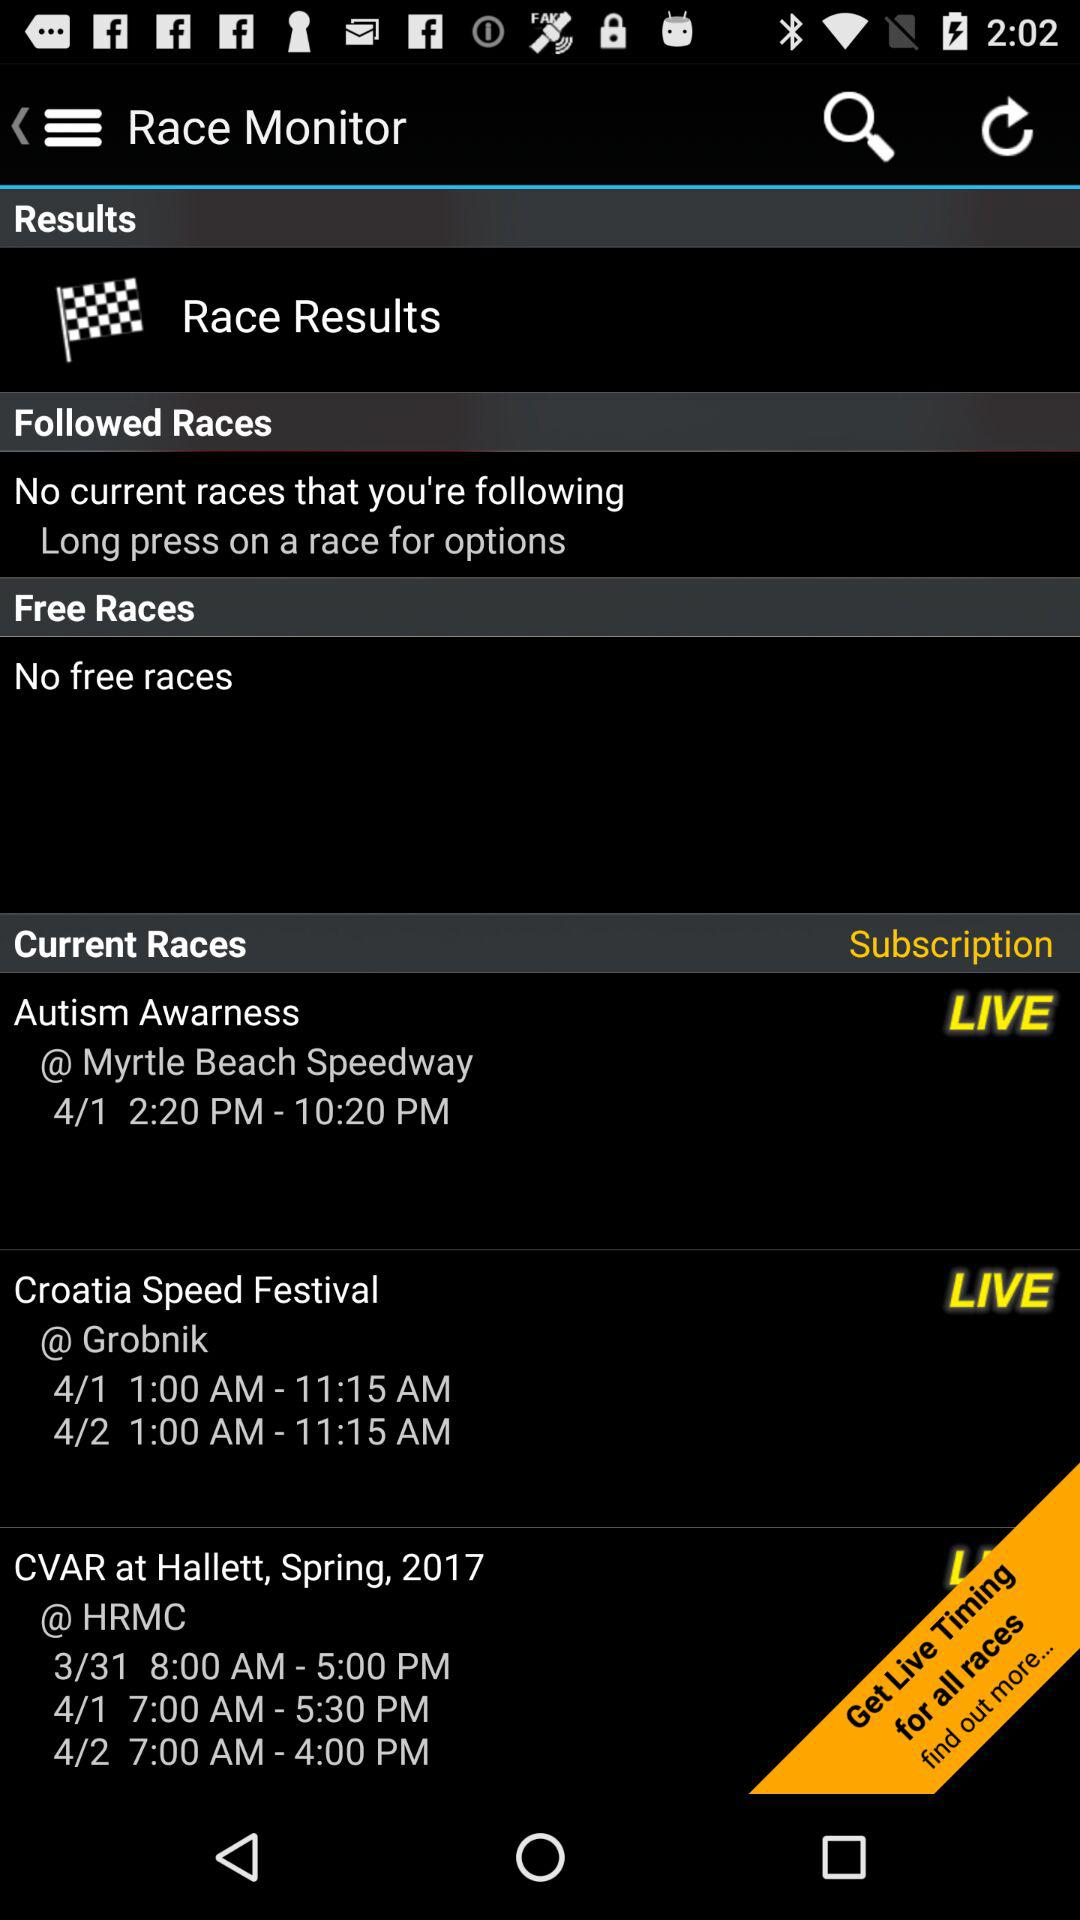What is the timing of the Croatia Speed Festival? The time is 1:00 AM - 11:15 AM. 